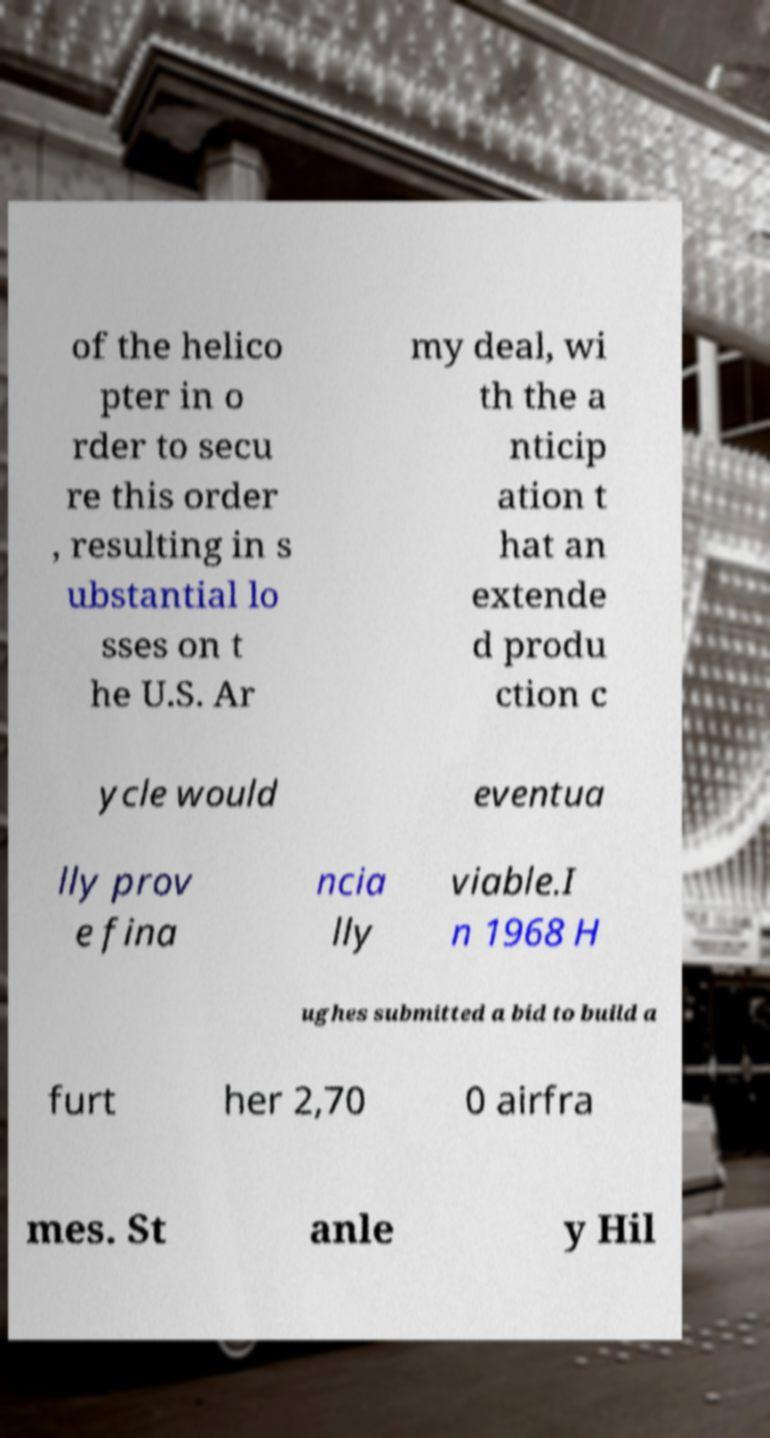What messages or text are displayed in this image? I need them in a readable, typed format. of the helico pter in o rder to secu re this order , resulting in s ubstantial lo sses on t he U.S. Ar my deal, wi th the a nticip ation t hat an extende d produ ction c ycle would eventua lly prov e fina ncia lly viable.I n 1968 H ughes submitted a bid to build a furt her 2,70 0 airfra mes. St anle y Hil 